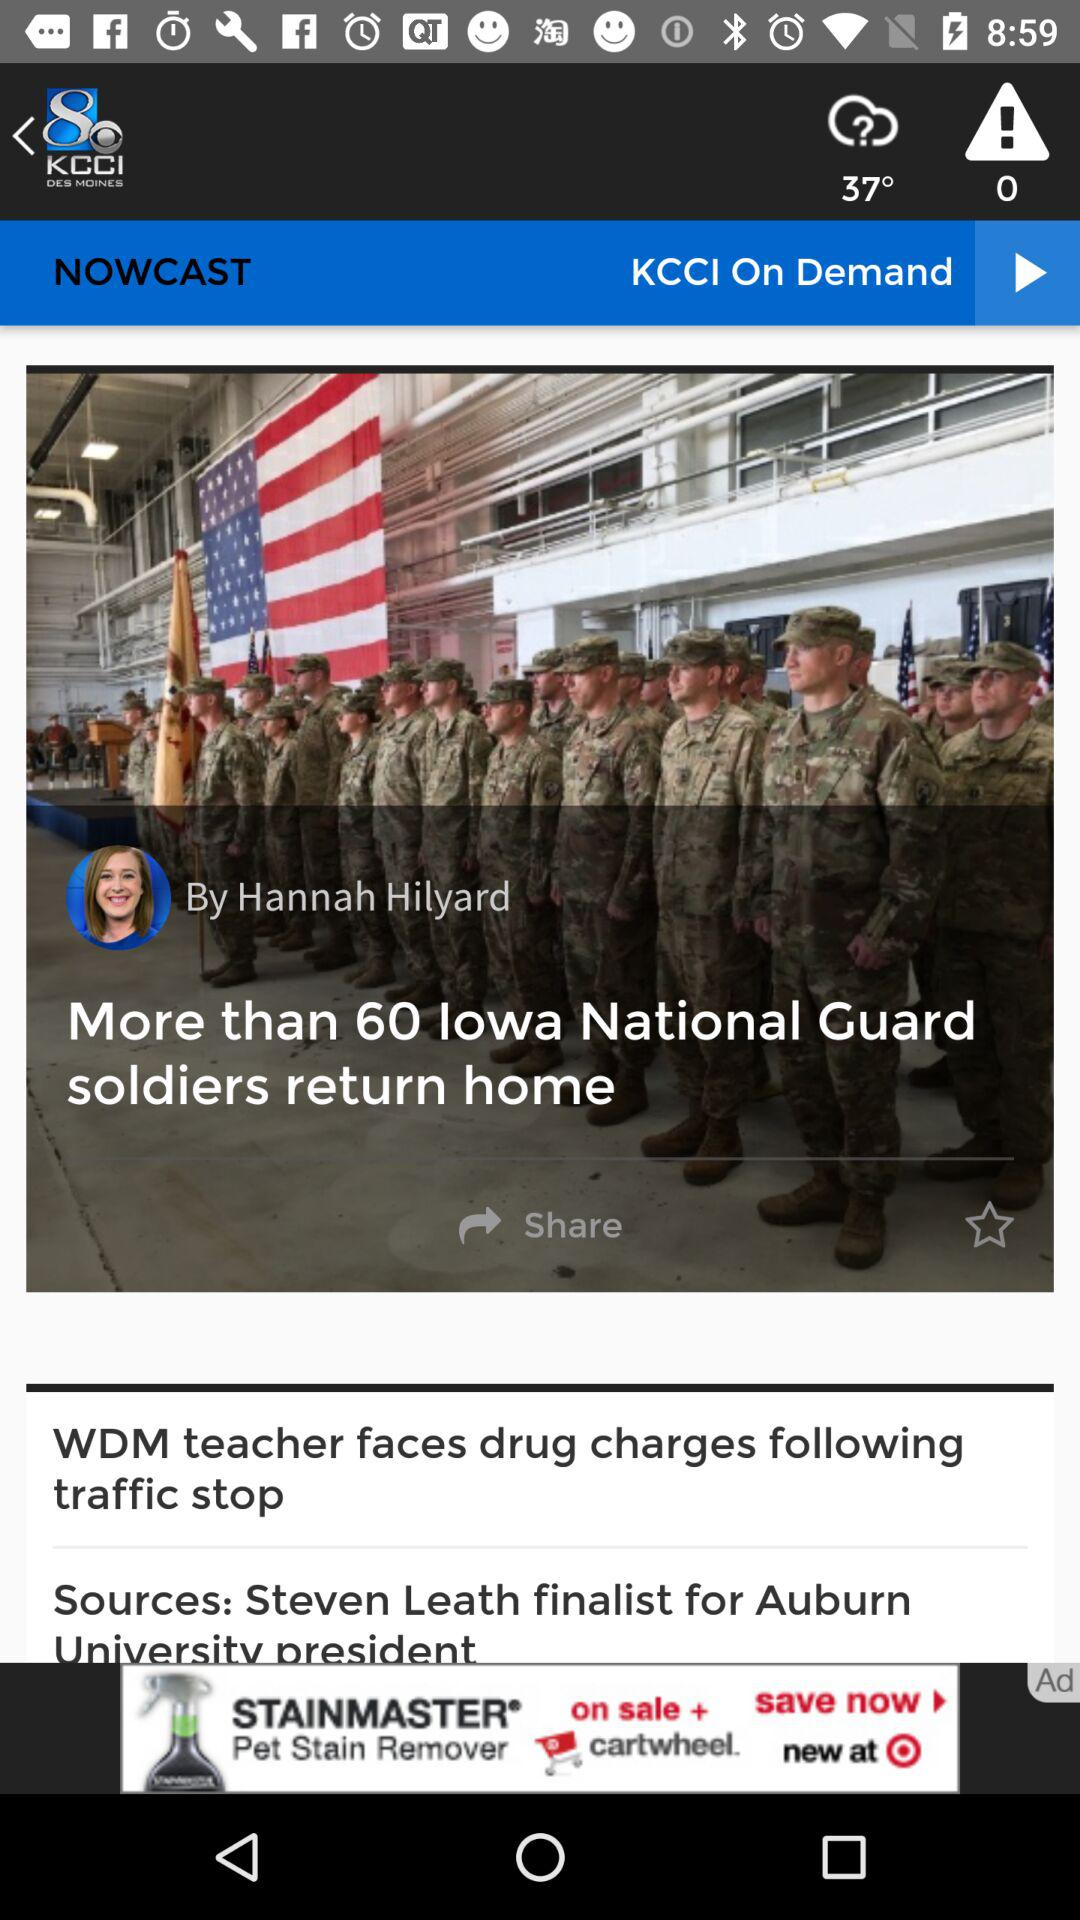Who is the author? The author is Hannah Hilyard. 